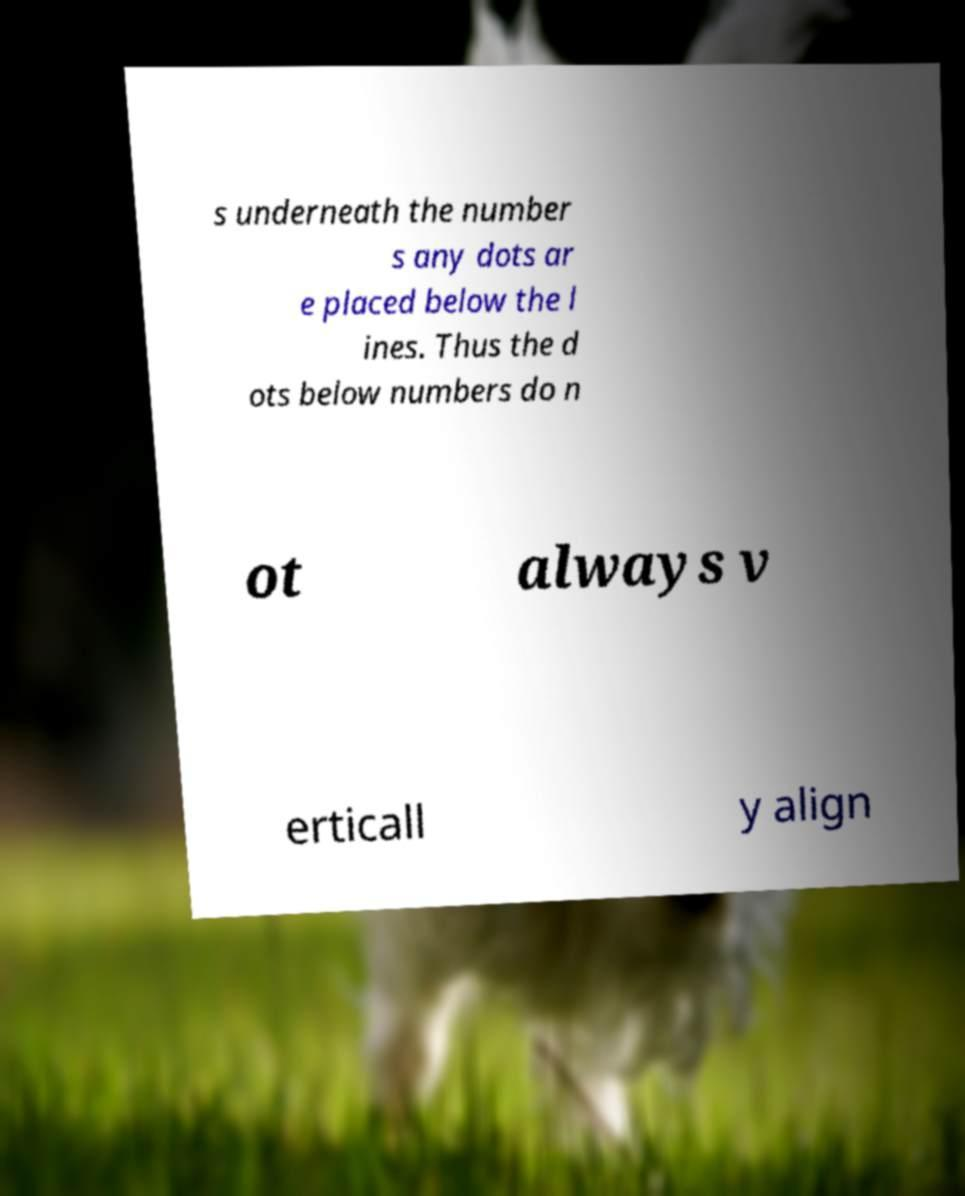Can you read and provide the text displayed in the image?This photo seems to have some interesting text. Can you extract and type it out for me? s underneath the number s any dots ar e placed below the l ines. Thus the d ots below numbers do n ot always v erticall y align 